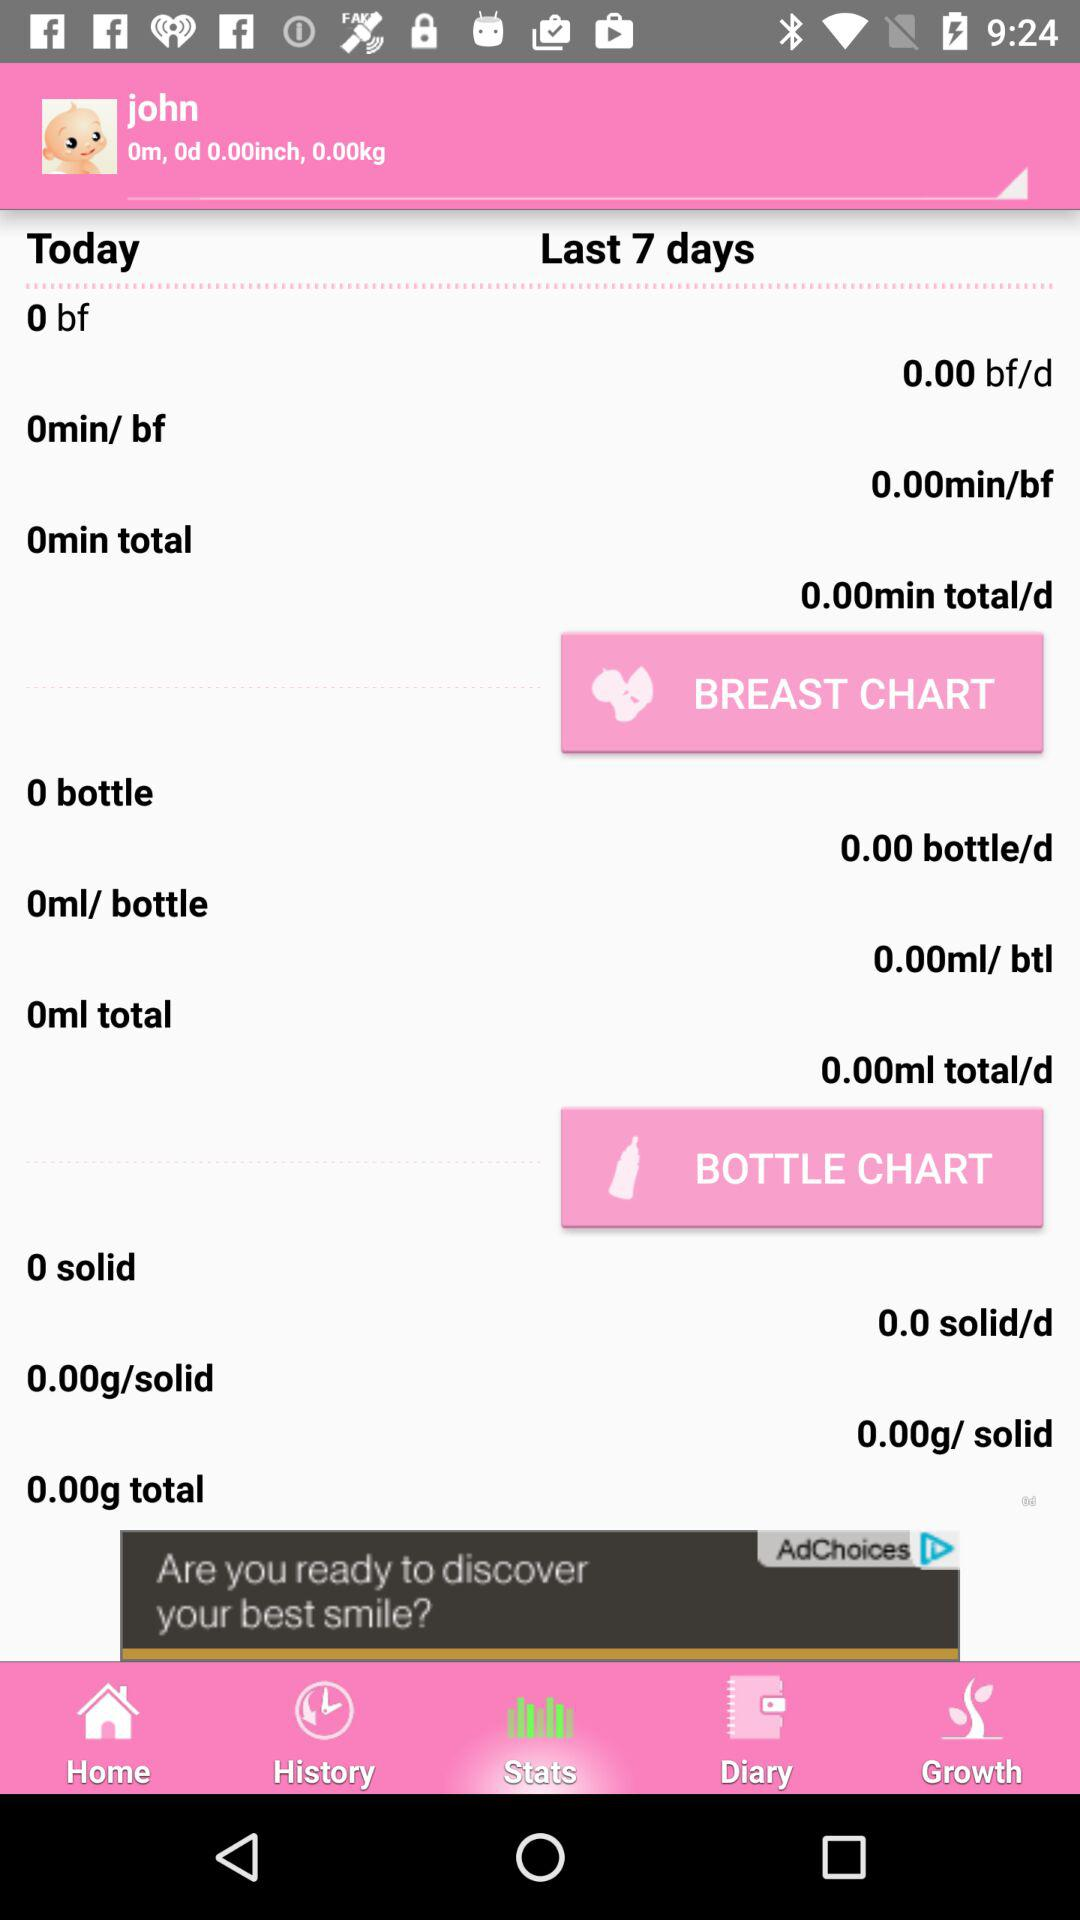What is the selected tab? The selected tab is "Stats". 